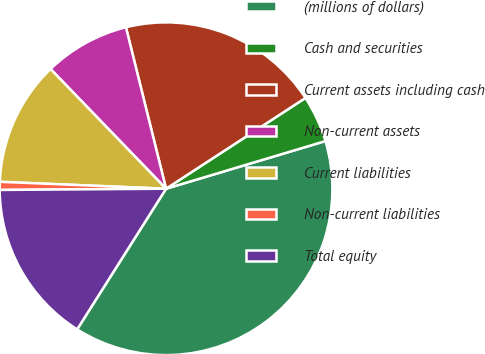Convert chart to OTSL. <chart><loc_0><loc_0><loc_500><loc_500><pie_chart><fcel>(millions of dollars)<fcel>Cash and securities<fcel>Current assets including cash<fcel>Non-current assets<fcel>Current liabilities<fcel>Non-current liabilities<fcel>Total equity<nl><fcel>38.6%<fcel>4.56%<fcel>19.69%<fcel>8.34%<fcel>12.12%<fcel>0.78%<fcel>15.91%<nl></chart> 